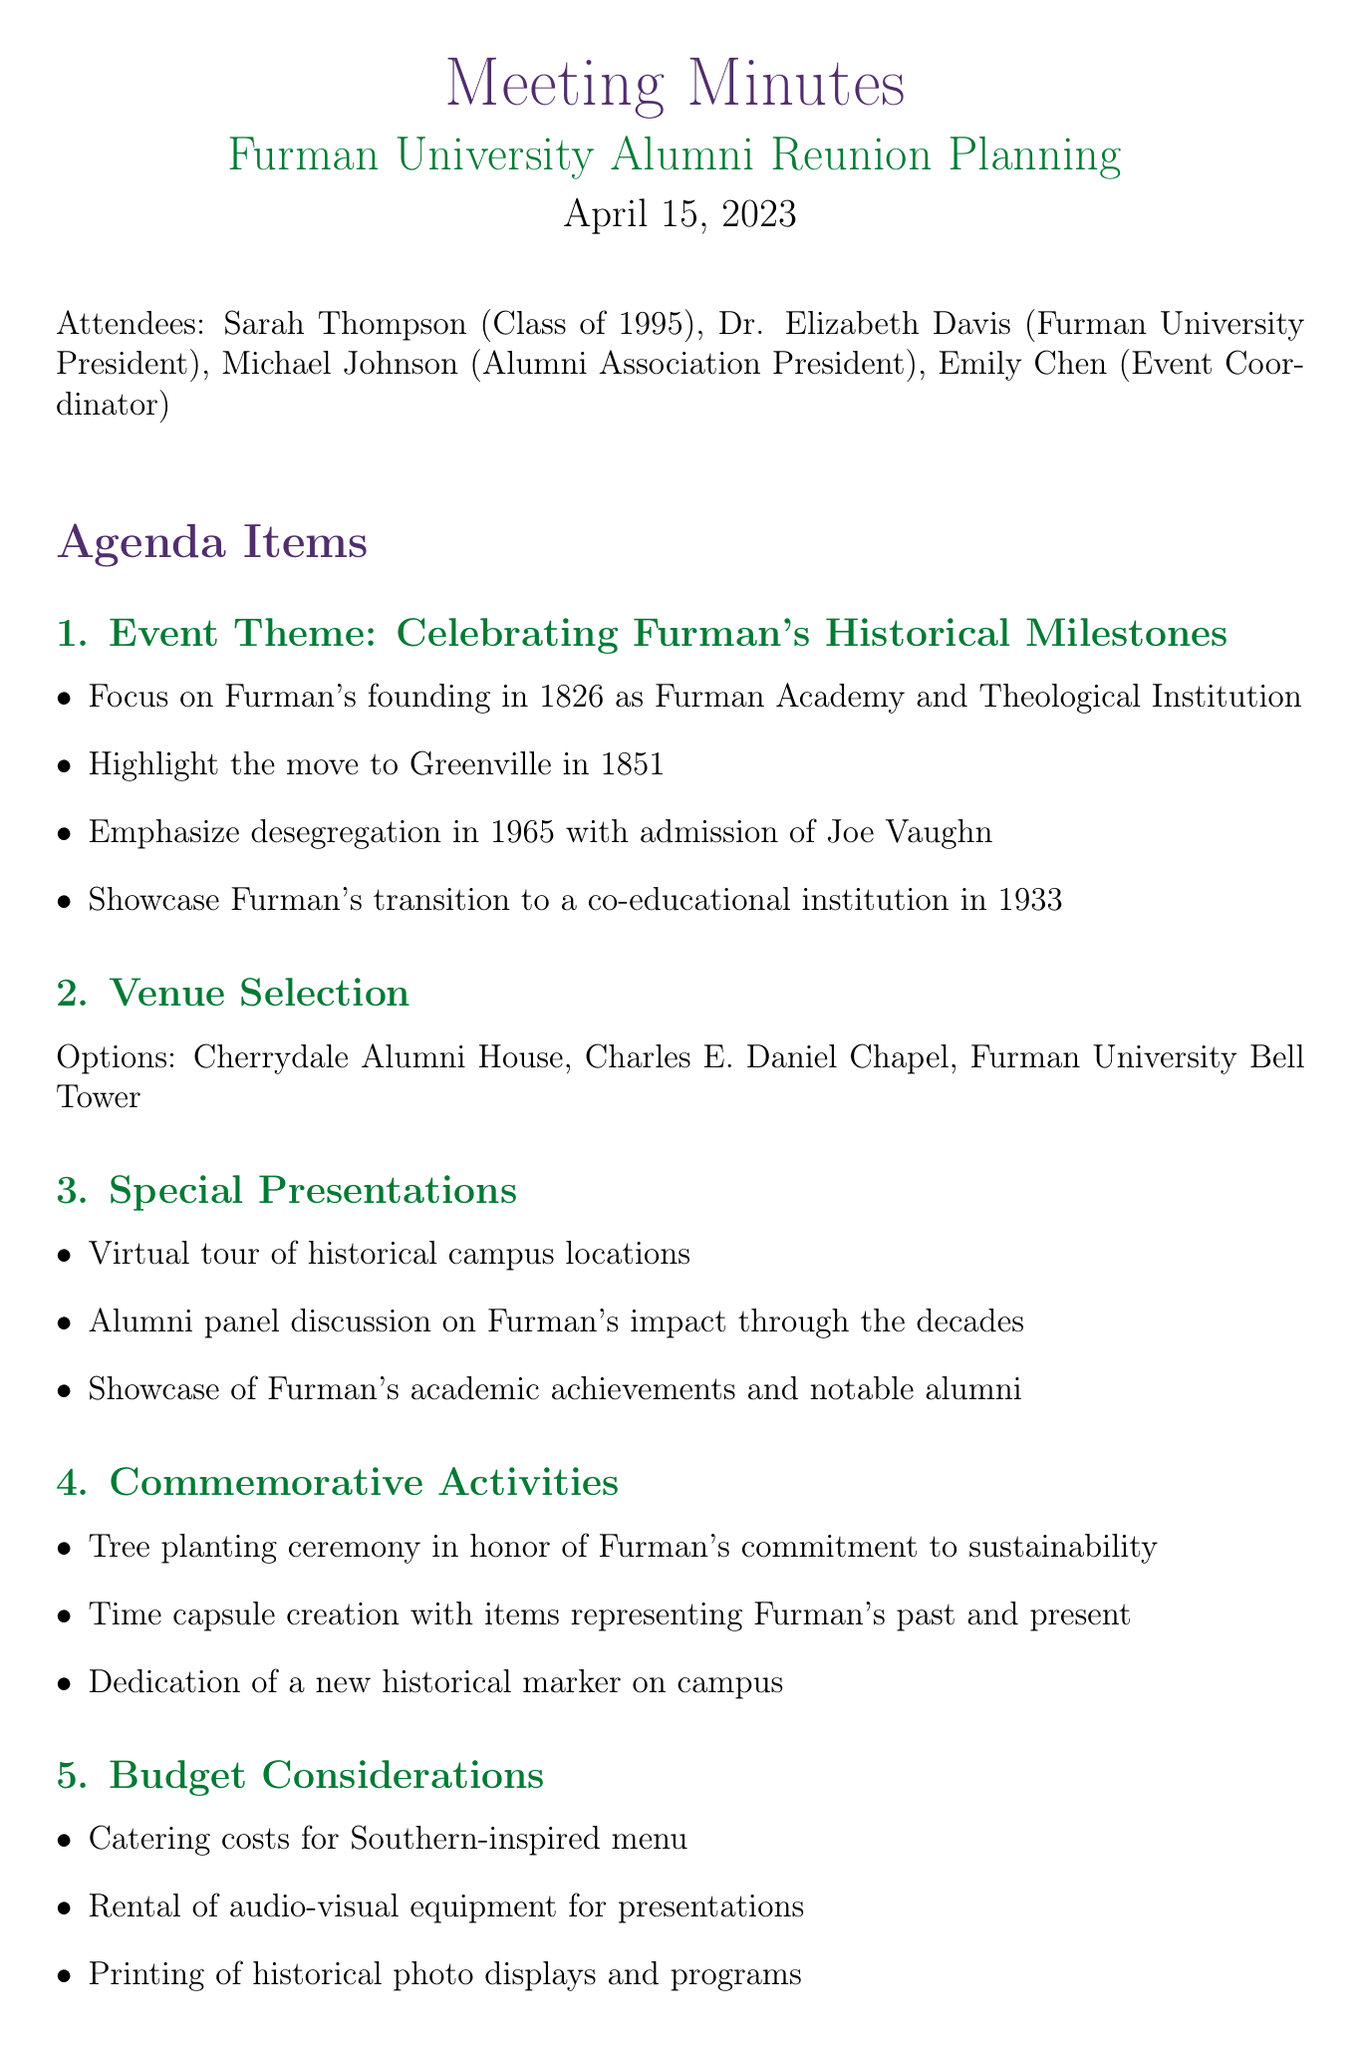What is the meeting title? The meeting title is stated at the beginning of the document.
Answer: Furman University Alumni Reunion Planning Who is the president of Furman University? The document lists attendees, including the president's name.
Answer: Dr. Elizabeth Davis In what year was Furman founded? The founding year is mentioned as a significant historical milestone.
Answer: 1826 What significant event occurred in 1965? A key historical moment regarding desegregation is noted in the discussion points.
Answer: Admission of Joe Vaughn What is one of the venue options for the reunion event? Venue options are explicitly listed in the meeting minutes.
Answer: Cherrydale Alumni House What type of ceremony is proposed to honor sustainability? The document suggests specific commemorative activities related to sustainability.
Answer: Tree planting ceremony How many action items are listed under next steps? The number of items listed in the "Next Steps" section indicates planned actions.
Answer: 3 What is one of the suggested special presentations? The discussion includes suggestions for special presentations at the reunion.
Answer: Virtual tour of historical campus locations What date was the meeting held? The date of the meeting is clearly mentioned in the header.
Answer: April 15, 2023 